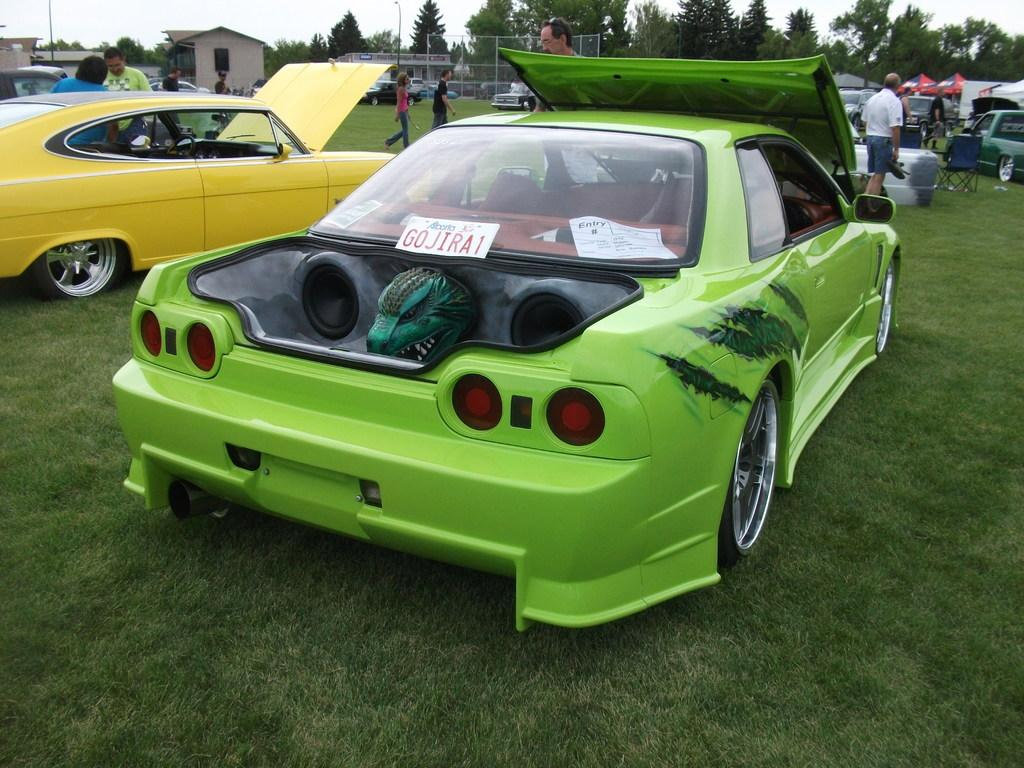<image>
Give a short and clear explanation of the subsequent image. green car with monster head in trunk and license plate G0JIRA1 against rear window 